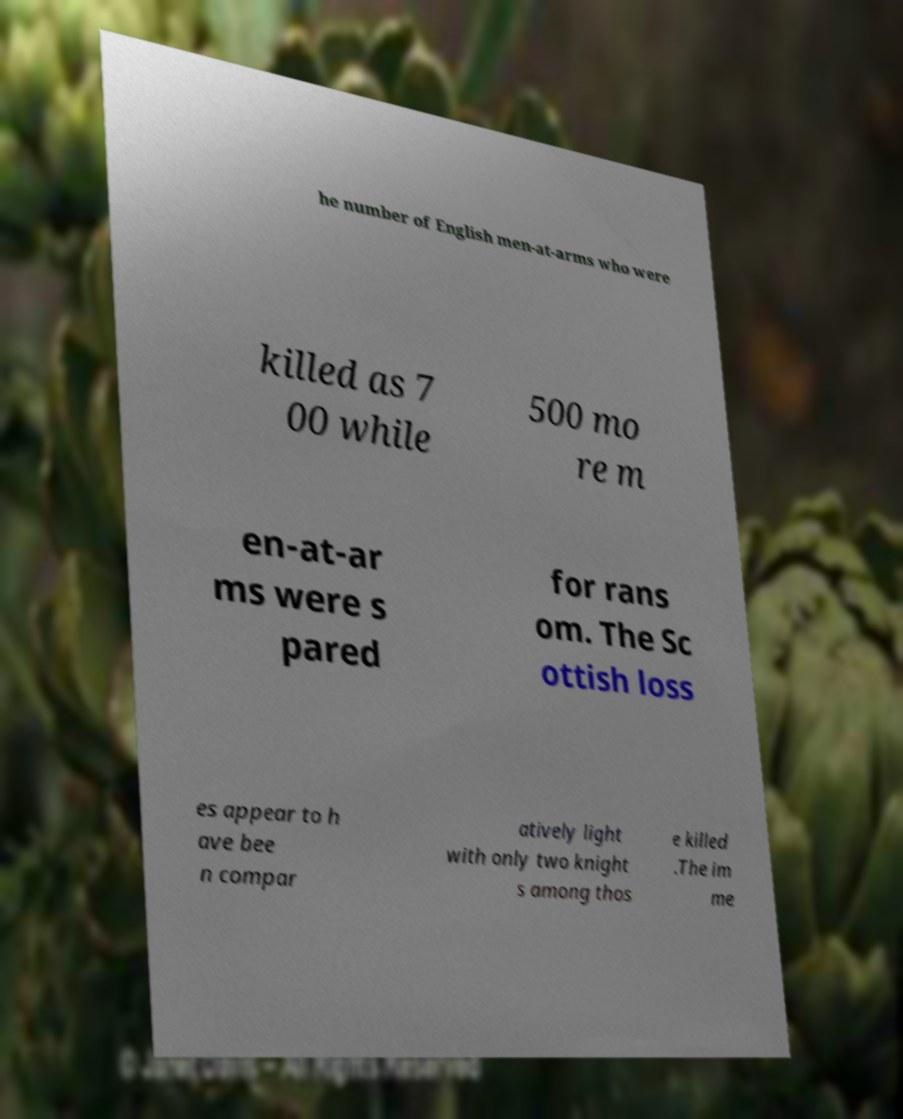Please read and relay the text visible in this image. What does it say? he number of English men-at-arms who were killed as 7 00 while 500 mo re m en-at-ar ms were s pared for rans om. The Sc ottish loss es appear to h ave bee n compar atively light with only two knight s among thos e killed .The im me 